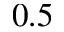<formula> <loc_0><loc_0><loc_500><loc_500>0 . 5</formula> 